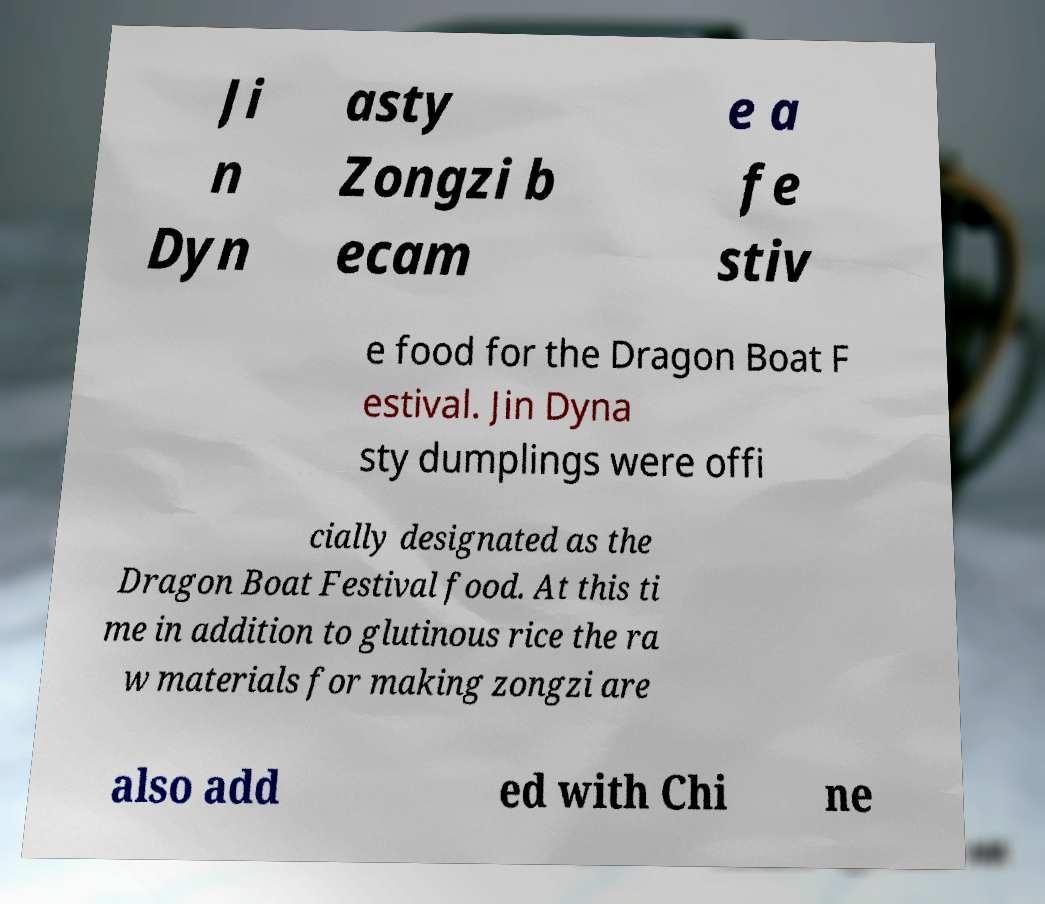Please identify and transcribe the text found in this image. Ji n Dyn asty Zongzi b ecam e a fe stiv e food for the Dragon Boat F estival. Jin Dyna sty dumplings were offi cially designated as the Dragon Boat Festival food. At this ti me in addition to glutinous rice the ra w materials for making zongzi are also add ed with Chi ne 